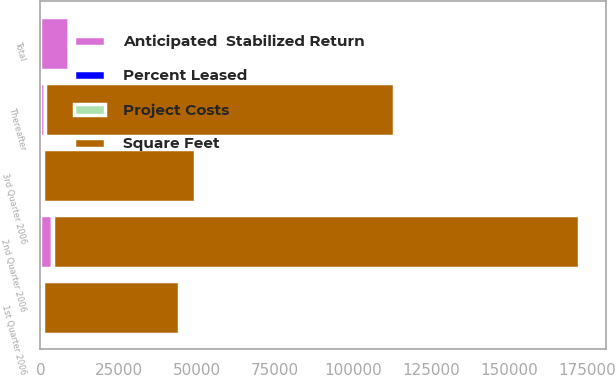<chart> <loc_0><loc_0><loc_500><loc_500><stacked_bar_chart><ecel><fcel>1st Quarter 2006<fcel>2nd Quarter 2006<fcel>3rd Quarter 2006<fcel>Thereafter<fcel>Total<nl><fcel>Anticipated  Stabilized Return<fcel>844<fcel>3852<fcel>727<fcel>1385<fcel>9004<nl><fcel>Project Costs<fcel>16<fcel>32<fcel>26<fcel>62<fcel>42<nl><fcel>Square Feet<fcel>43379<fcel>168286<fcel>48682<fcel>111588<fcel>62<nl><fcel>Percent Leased<fcel>9.7<fcel>9.6<fcel>9.8<fcel>9.4<fcel>9.3<nl></chart> 